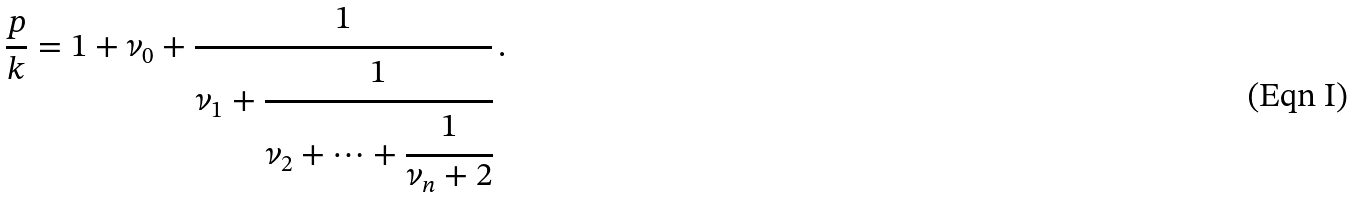Convert formula to latex. <formula><loc_0><loc_0><loc_500><loc_500>\frac { p } { k } = 1 + \nu _ { 0 } + \cfrac { 1 } { \nu _ { 1 } + \cfrac { 1 } { \nu _ { 2 } + \dots + \cfrac { 1 } { \nu _ { n } + 2 } } } \, .</formula> 